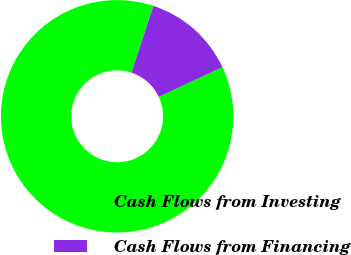Convert chart. <chart><loc_0><loc_0><loc_500><loc_500><pie_chart><fcel>Cash Flows from Investing<fcel>Cash Flows from Financing<nl><fcel>87.0%<fcel>13.0%<nl></chart> 